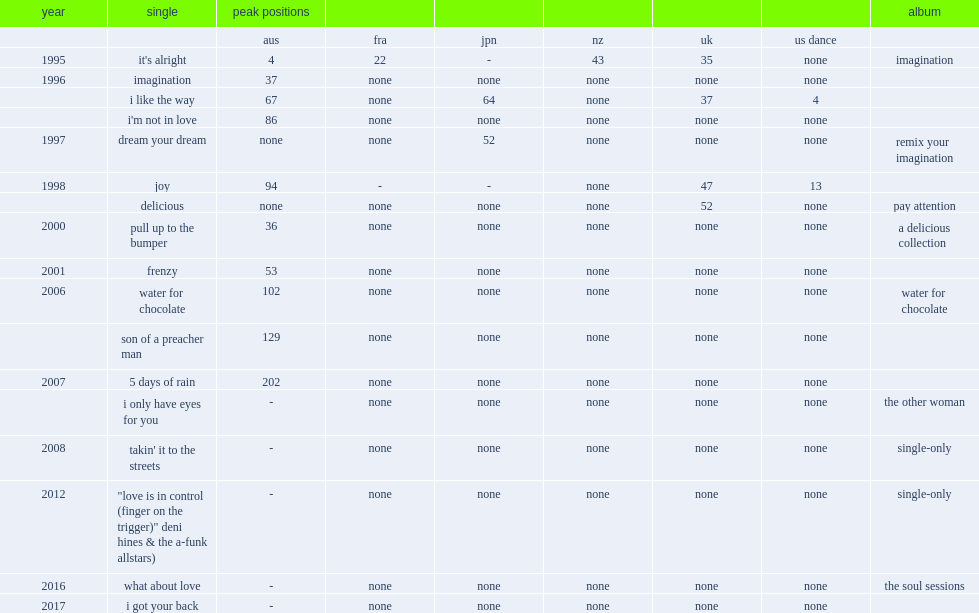Which album of hines' single was released in 2006? Water for chocolate. 